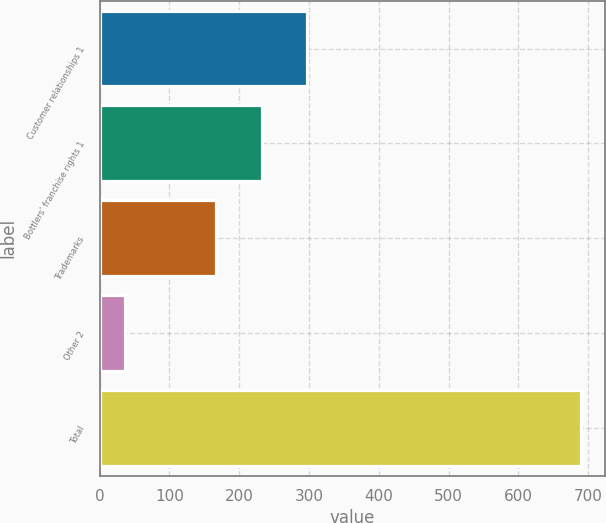<chart> <loc_0><loc_0><loc_500><loc_500><bar_chart><fcel>Customer relationships 1<fcel>Bottlers' franchise rights 1<fcel>Trademarks<fcel>Other 2<fcel>Total<nl><fcel>297.6<fcel>232.3<fcel>167<fcel>37<fcel>690<nl></chart> 